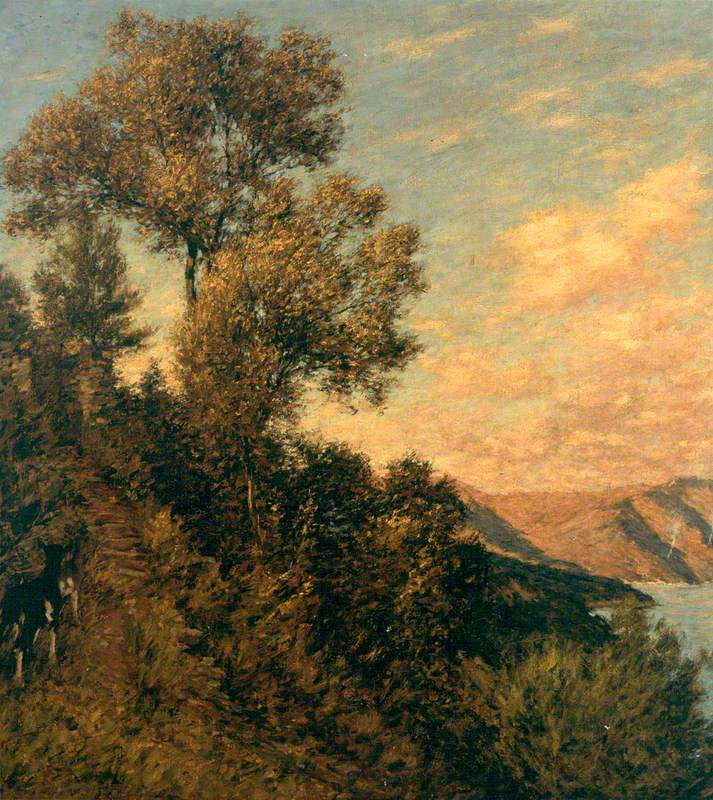What is this photo about? The image displays a masterful impressionist painting, likely from the late 19th century, capturing a serene landscape. The towering presence of a tree on a cliff edge draws the eye, as it overlooks a tranquil expanse of water. The vibrant green foliage contrasts dramatically with the warm, glowing tones of the sky, potentially indicative of the golden hour just after sunrise or before sunset. This composition, with its lively yet controlled brushstrokes, not only reflects the natural beauty and temporary moments typical of Impressionism but also conveys a sense of enduring calm, prompting viewers to ponder the intimate relationship between nature and the passage of time. 